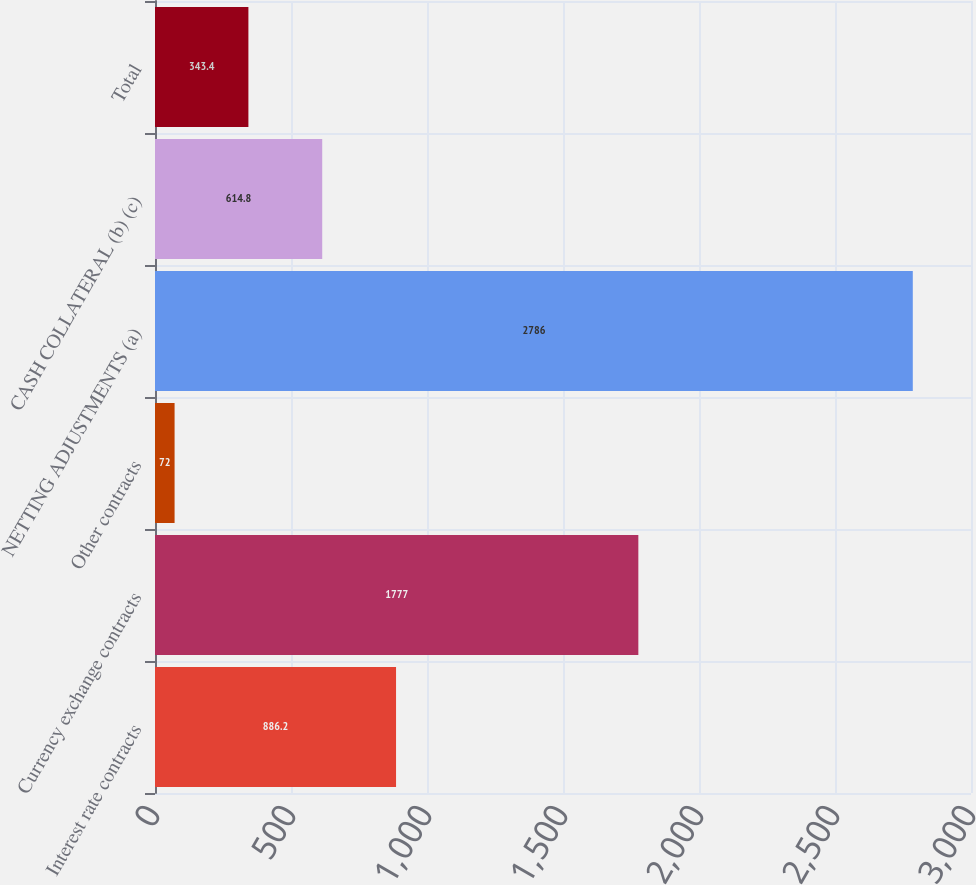<chart> <loc_0><loc_0><loc_500><loc_500><bar_chart><fcel>Interest rate contracts<fcel>Currency exchange contracts<fcel>Other contracts<fcel>NETTING ADJUSTMENTS (a)<fcel>CASH COLLATERAL (b) (c)<fcel>Total<nl><fcel>886.2<fcel>1777<fcel>72<fcel>2786<fcel>614.8<fcel>343.4<nl></chart> 